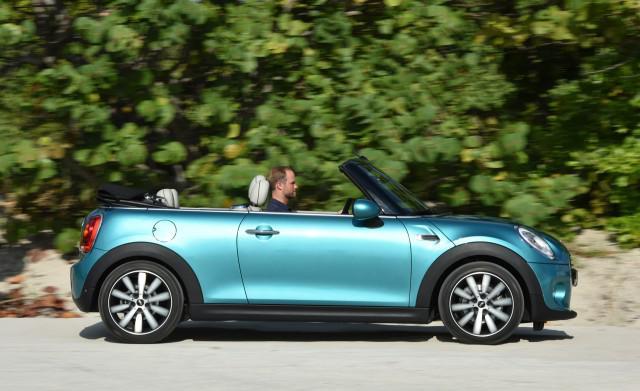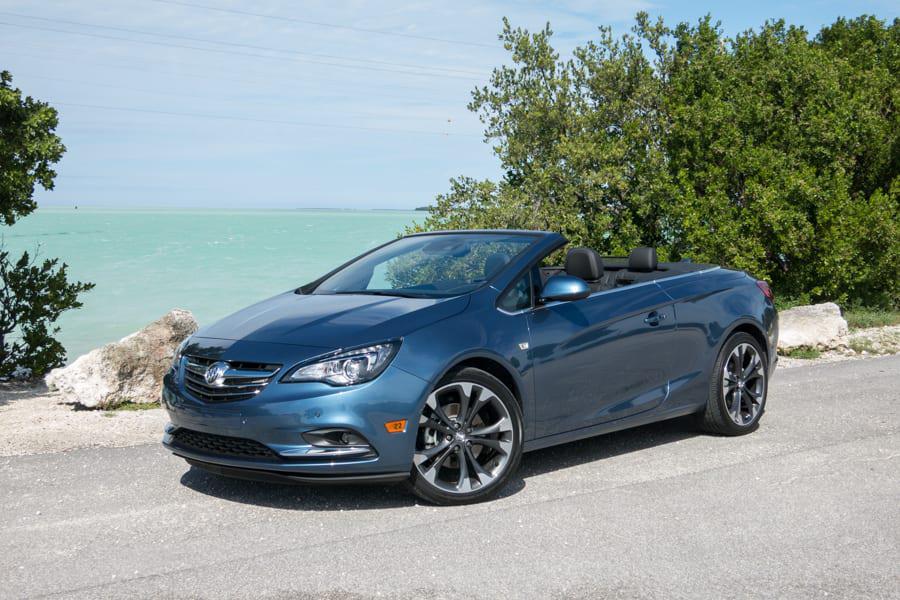The first image is the image on the left, the second image is the image on the right. Examine the images to the left and right. Is the description "One image shows a forward-angled medium-blue convertible with a windshield that slopes to the hood." accurate? Answer yes or no. Yes. The first image is the image on the left, the second image is the image on the right. Considering the images on both sides, is "The left image contains a convertible that is facing towards the left." valid? Answer yes or no. No. 